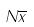<formula> <loc_0><loc_0><loc_500><loc_500>N \overline { x }</formula> 